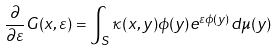<formula> <loc_0><loc_0><loc_500><loc_500>\frac { \partial } { \partial \varepsilon } G ( x , \varepsilon ) = \int _ { S } \kappa ( x , y ) \phi ( y ) e ^ { \varepsilon \phi ( y ) } d \mu ( y )</formula> 